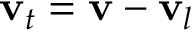Convert formula to latex. <formula><loc_0><loc_0><loc_500><loc_500>v _ { t } = v - v _ { l }</formula> 